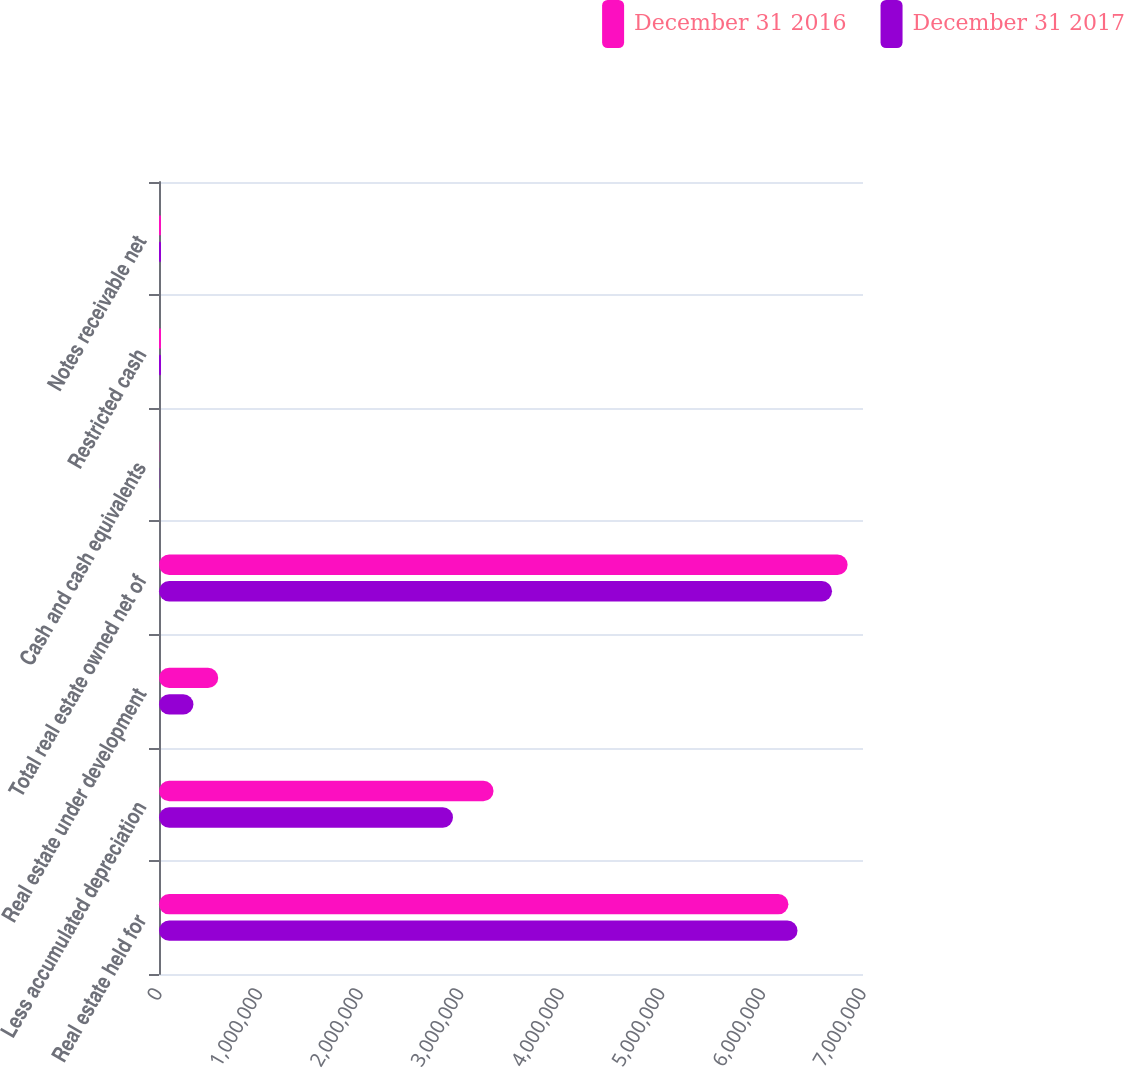<chart> <loc_0><loc_0><loc_500><loc_500><stacked_bar_chart><ecel><fcel>Real estate held for<fcel>Less accumulated depreciation<fcel>Real estate under development<fcel>Total real estate owned net of<fcel>Cash and cash equivalents<fcel>Restricted cash<fcel>Notes receivable net<nl><fcel>December 31 2016<fcel>6.2584e+06<fcel>3.32631e+06<fcel>588636<fcel>6.84704e+06<fcel>2038<fcel>19792<fcel>19469<nl><fcel>December 31 2017<fcel>6.34878e+06<fcel>2.92307e+06<fcel>342282<fcel>6.69213e+06<fcel>2112<fcel>19994<fcel>19790<nl></chart> 